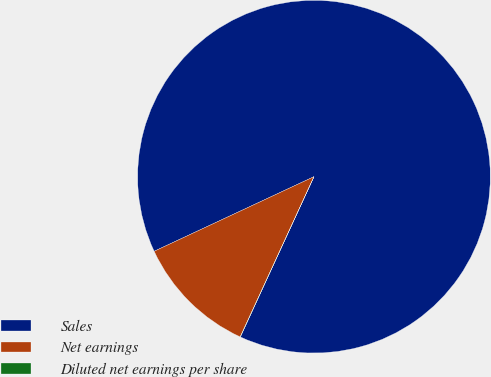<chart> <loc_0><loc_0><loc_500><loc_500><pie_chart><fcel>Sales<fcel>Net earnings<fcel>Diluted net earnings per share<nl><fcel>88.81%<fcel>11.18%<fcel>0.02%<nl></chart> 